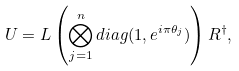<formula> <loc_0><loc_0><loc_500><loc_500>U = L \left ( \bigotimes _ { j = 1 } ^ { n } d i a g ( 1 , e ^ { i \pi \theta _ { j } } ) \right ) R ^ { \dagger } ,</formula> 